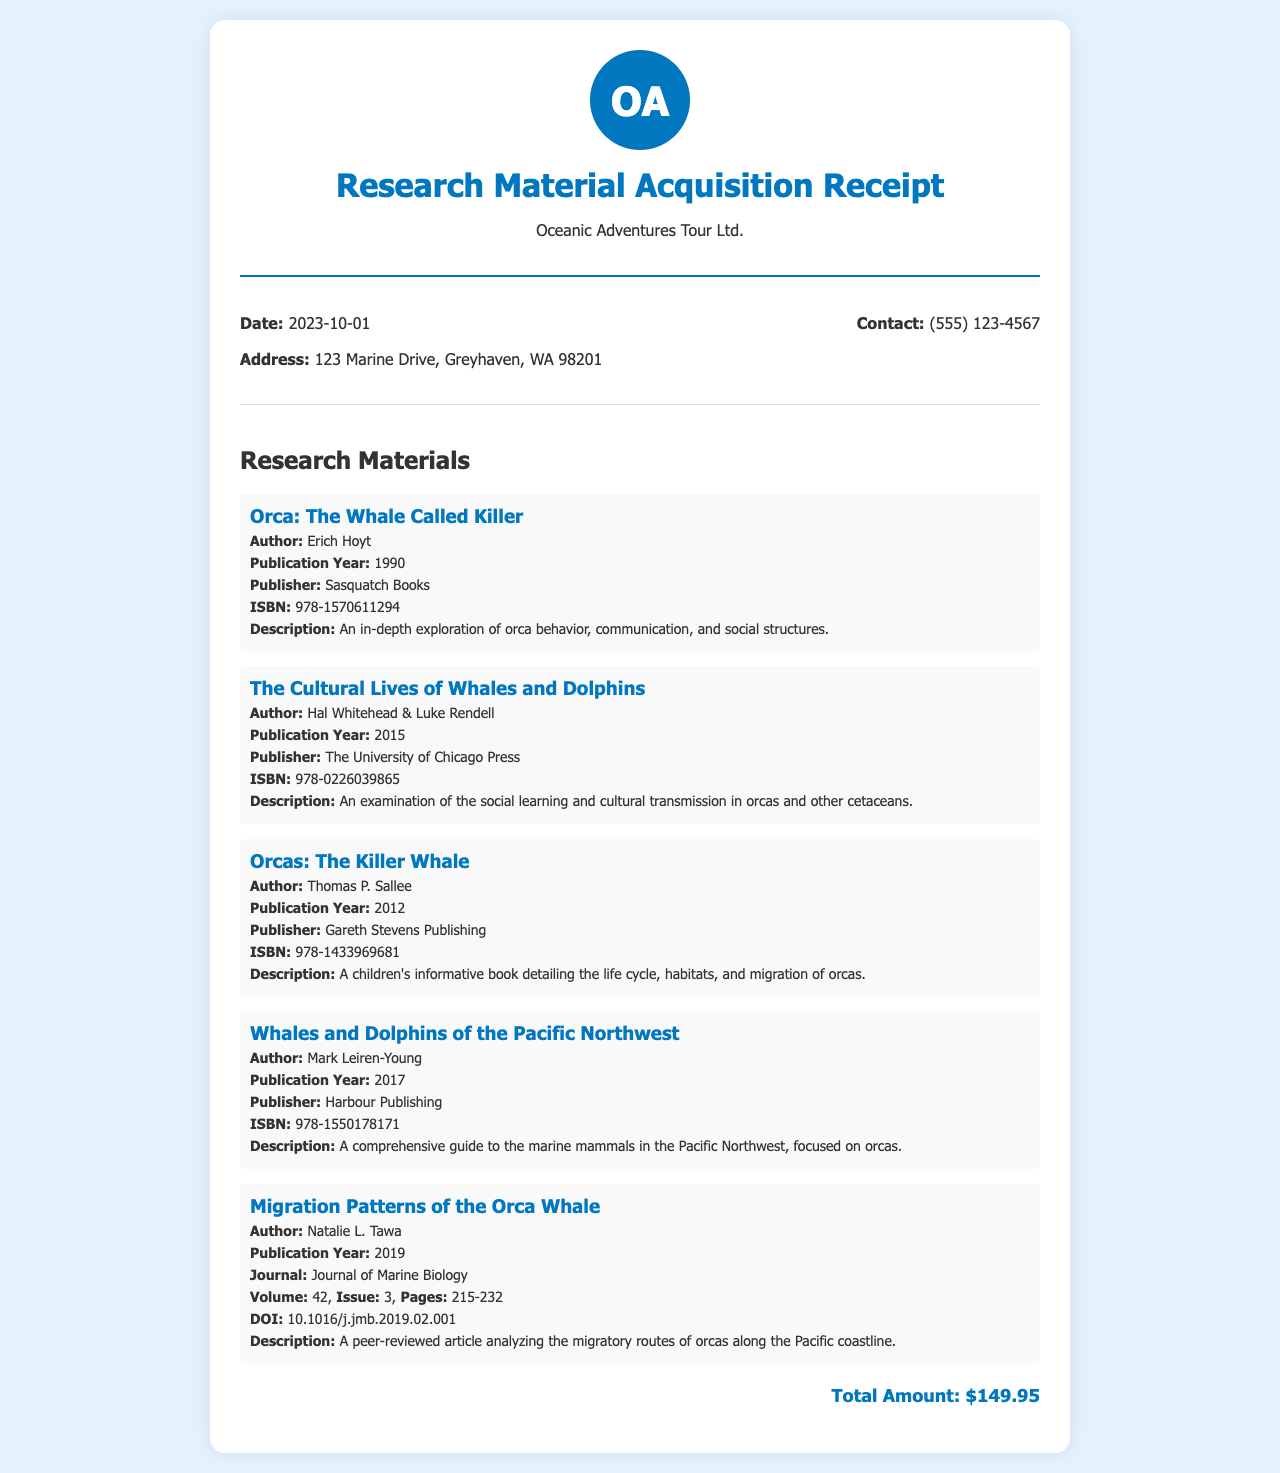What is the date of the receipt? The date of the receipt is specified in the document, which is 2023-10-01.
Answer: 2023-10-01 Who is the author of the book "Orca: The Whale Called Killer"? The author is listed in the details of the book in the document, which is Erich Hoyt.
Answer: Erich Hoyt What is the total amount of the receipt? The total amount is stated at the end of the receipt, clearly showing the total cost as $149.95.
Answer: $149.95 What is the ISBN of "Whales and Dolphins of the Pacific Northwest"? The ISBN can be found in the details of the book section of the document, which is 978-1550178171.
Answer: 978-1550178171 Which journal published the article "Migration Patterns of the Orca Whale"? The journal where the article was published is mentioned in its details, which is Journal of Marine Biology.
Answer: Journal of Marine Biology How many materials are listed in the receipt? The number of materials can be counted in the materials section of the document, where there are five distinct entries.
Answer: Five What is the publication year of "The Cultural Lives of Whales and Dolphins"? The publication year is included in the details of the book, which is 2015.
Answer: 2015 What is the DOI for the article "Migration Patterns of the Orca Whale"? The DOI is presented in the details of the article within the document as 10.1016/j.jmb.2019.02.001.
Answer: 10.1016/j.jmb.2019.02.001 